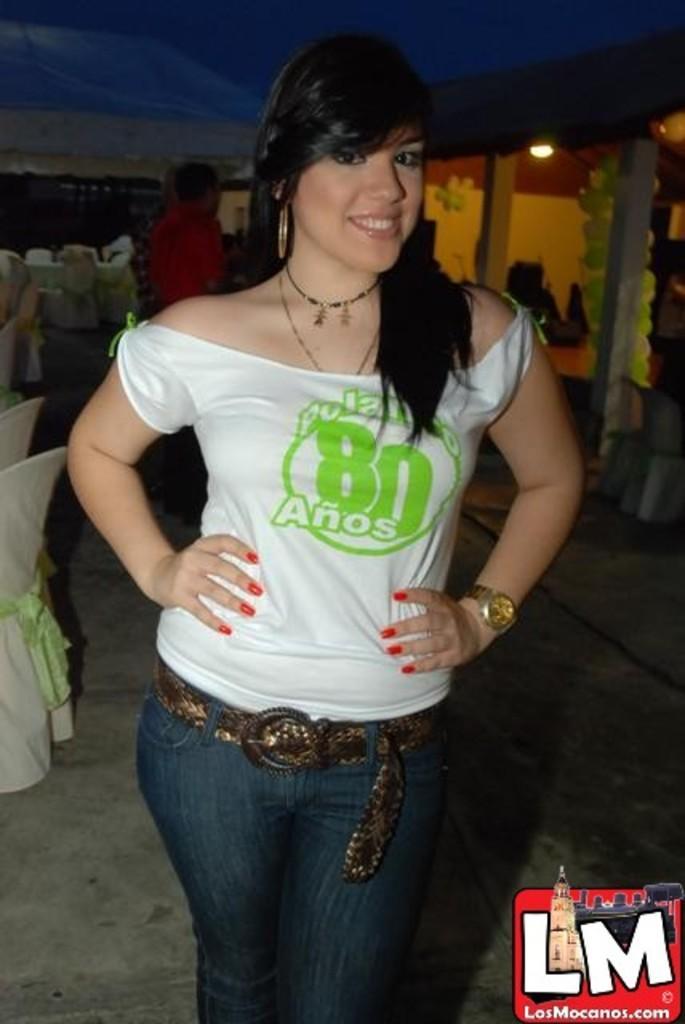How would you summarize this image in a sentence or two? In this picture we can see the girl wearing white t-shirt and jeans, standing in the front giving a pose to the camera. Behind we can see the white table and chairs. In the background there is a shade and light. 